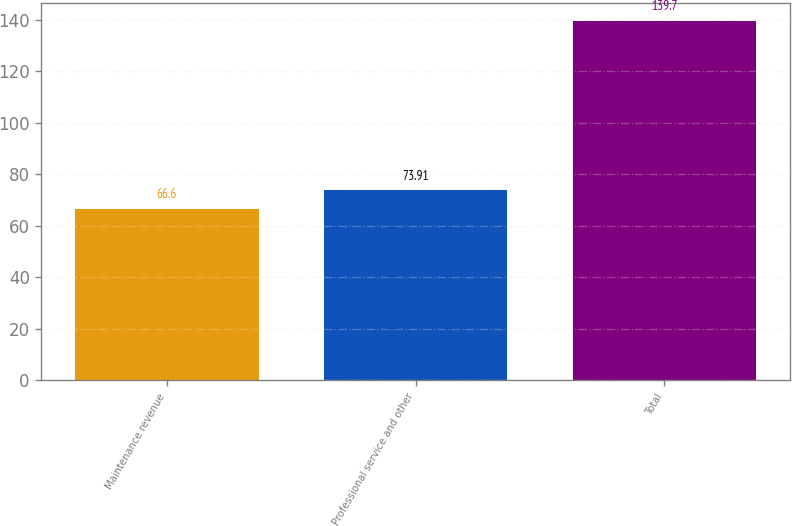Convert chart. <chart><loc_0><loc_0><loc_500><loc_500><bar_chart><fcel>Maintenance revenue<fcel>Professional service and other<fcel>Total<nl><fcel>66.6<fcel>73.91<fcel>139.7<nl></chart> 